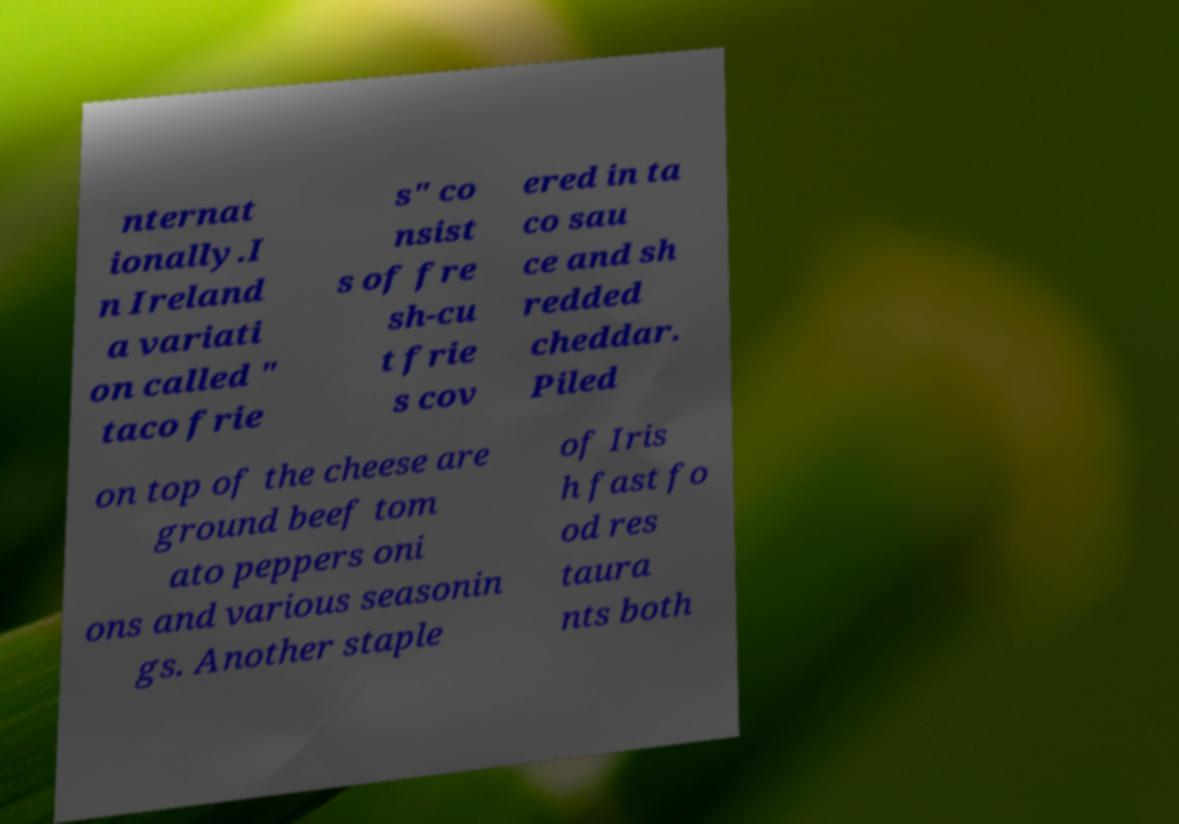Can you accurately transcribe the text from the provided image for me? nternat ionally.I n Ireland a variati on called " taco frie s" co nsist s of fre sh-cu t frie s cov ered in ta co sau ce and sh redded cheddar. Piled on top of the cheese are ground beef tom ato peppers oni ons and various seasonin gs. Another staple of Iris h fast fo od res taura nts both 